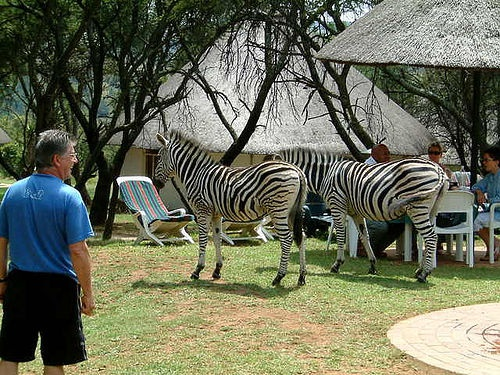Describe the objects in this image and their specific colors. I can see people in darkgreen, black, navy, blue, and maroon tones, zebra in darkgreen, black, gray, and darkgray tones, umbrella in darkgreen, darkgray, lightgray, gray, and black tones, zebra in darkgreen, black, gray, darkgray, and ivory tones, and chair in darkgreen, darkgray, gray, black, and white tones in this image. 